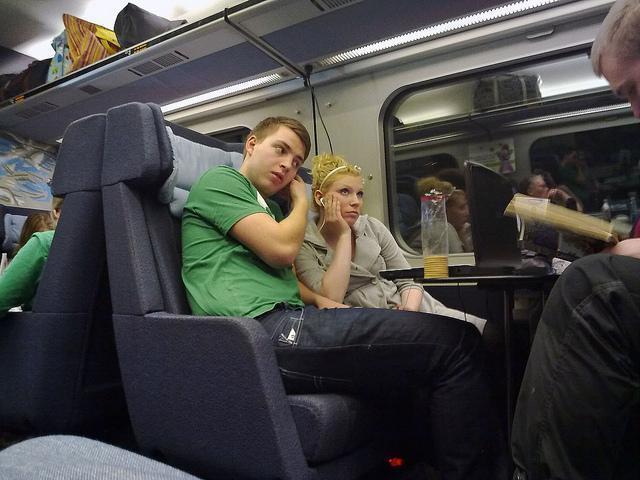What are the two young people doing with the headphones?
Answer the question by selecting the correct answer among the 4 following choices.
Options: Listening, pulling, gaming, fighting. Listening. 